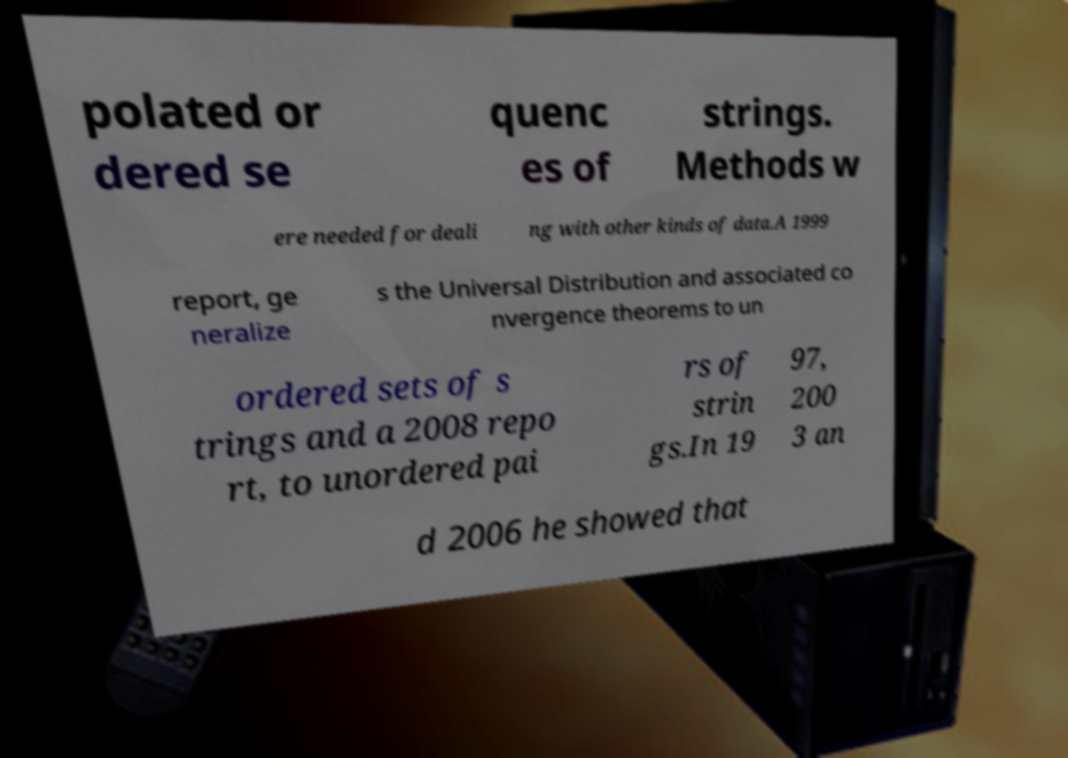Please read and relay the text visible in this image. What does it say? polated or dered se quenc es of strings. Methods w ere needed for deali ng with other kinds of data.A 1999 report, ge neralize s the Universal Distribution and associated co nvergence theorems to un ordered sets of s trings and a 2008 repo rt, to unordered pai rs of strin gs.In 19 97, 200 3 an d 2006 he showed that 